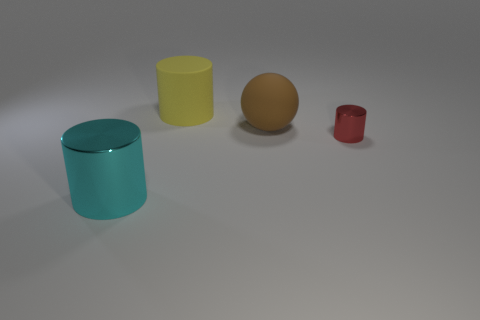What number of big brown matte objects are the same shape as the small red object?
Your answer should be very brief. 0. How many objects are either metal cylinders that are to the left of the small cylinder or big objects that are in front of the tiny thing?
Offer a very short reply. 1. The large object that is left of the large cylinder behind the cyan shiny cylinder that is to the left of the small red metal thing is made of what material?
Keep it short and to the point. Metal. Is the color of the big thing in front of the small cylinder the same as the matte cylinder?
Provide a succinct answer. No. There is a cylinder that is behind the cyan thing and left of the red shiny object; what material is it made of?
Offer a terse response. Rubber. Are there any red metallic cylinders of the same size as the yellow object?
Provide a short and direct response. No. What number of cyan shiny things are there?
Offer a very short reply. 1. There is a large brown object; how many brown matte objects are to the left of it?
Your answer should be compact. 0. Is the material of the red cylinder the same as the yellow cylinder?
Offer a terse response. No. How many cylinders are left of the matte sphere and in front of the matte ball?
Ensure brevity in your answer.  1. 